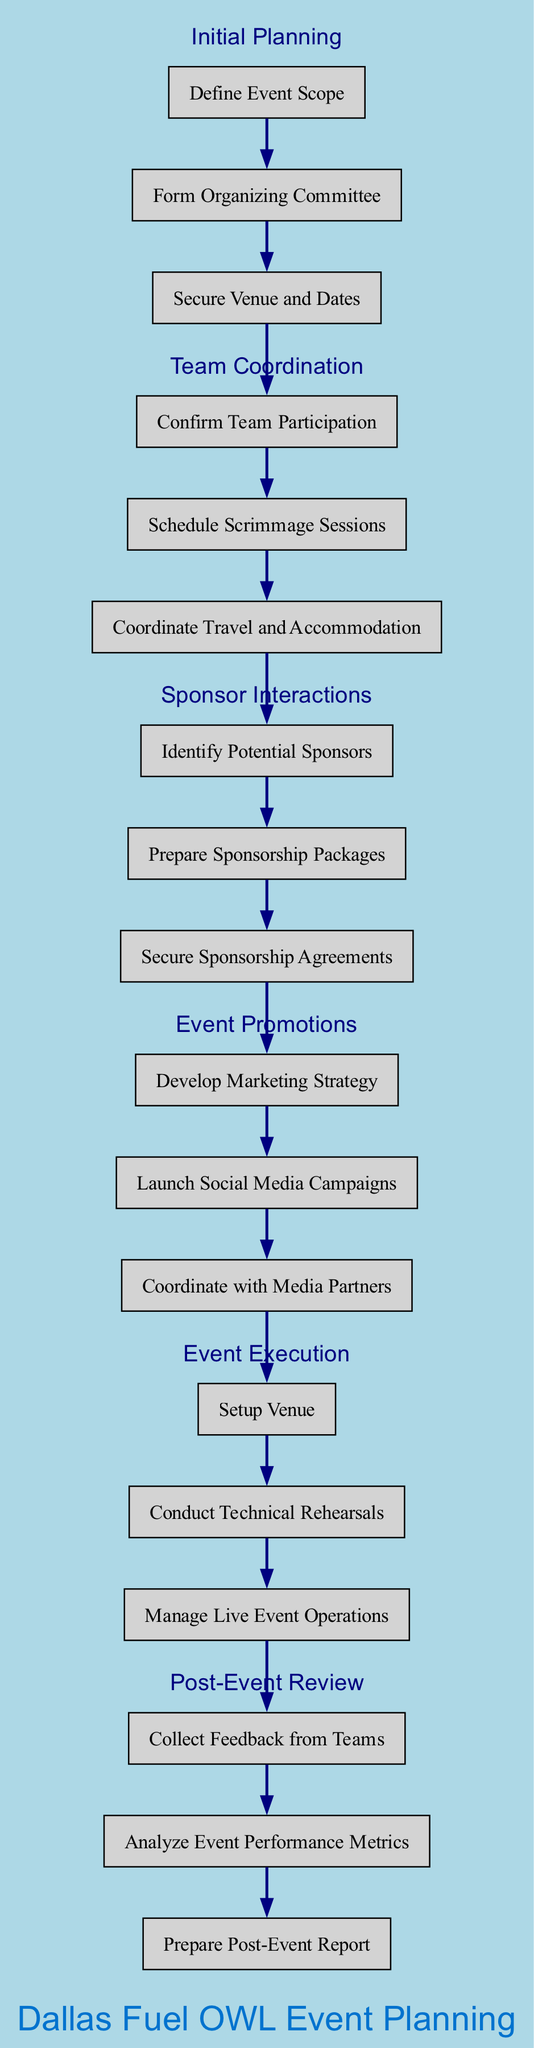What is the first step in the diagram? The diagram starts with the "Initial Planning" step, which is the first node in the flow.
Answer: Initial Planning How many tasks are there in "Team Coordination"? The "Team Coordination" step contains three tasks: "Confirm Team Participation," "Schedule Scrimmage Sessions," and "Coordinate Travel and Accommodation." Thus, there are three tasks.
Answer: 3 Which step comes immediately after "Sponsor Interactions"? "Event Promotions" comes directly after "Sponsor Interactions" in the flow of the diagram.
Answer: Event Promotions What color is used for the edges connecting the nodes? The edges in the diagram are colored navy, as specified in the graph attributes.
Answer: Navy How many total steps are depicted in this diagram? The diagram displays six distinct steps, as seen listed in the flow.
Answer: 6 What is the last task listed in "Post-Event Review"? The last task in the "Post-Event Review" step is "Prepare Post-Event Report." This is the third and final task in that section.
Answer: Prepare Post-Event Report Which two steps are directly connected by an edge? "Initial Planning" and "Team Coordination" are directly connected by an edge as they follow one another in the flowchart.
Answer: Initial Planning, Team Coordination Which step has tasks related to marketing? The "Event Promotions" step includes tasks specifically related to marketing strategies and social media campaigns.
Answer: Event Promotions What is the main theme of the diagram? The primary theme of the diagram is planning and preparing for a major Overwatch League event, as indicated by the title and the contents of the steps outlined.
Answer: Planning and Preparing for a Major Overwatch League Event 